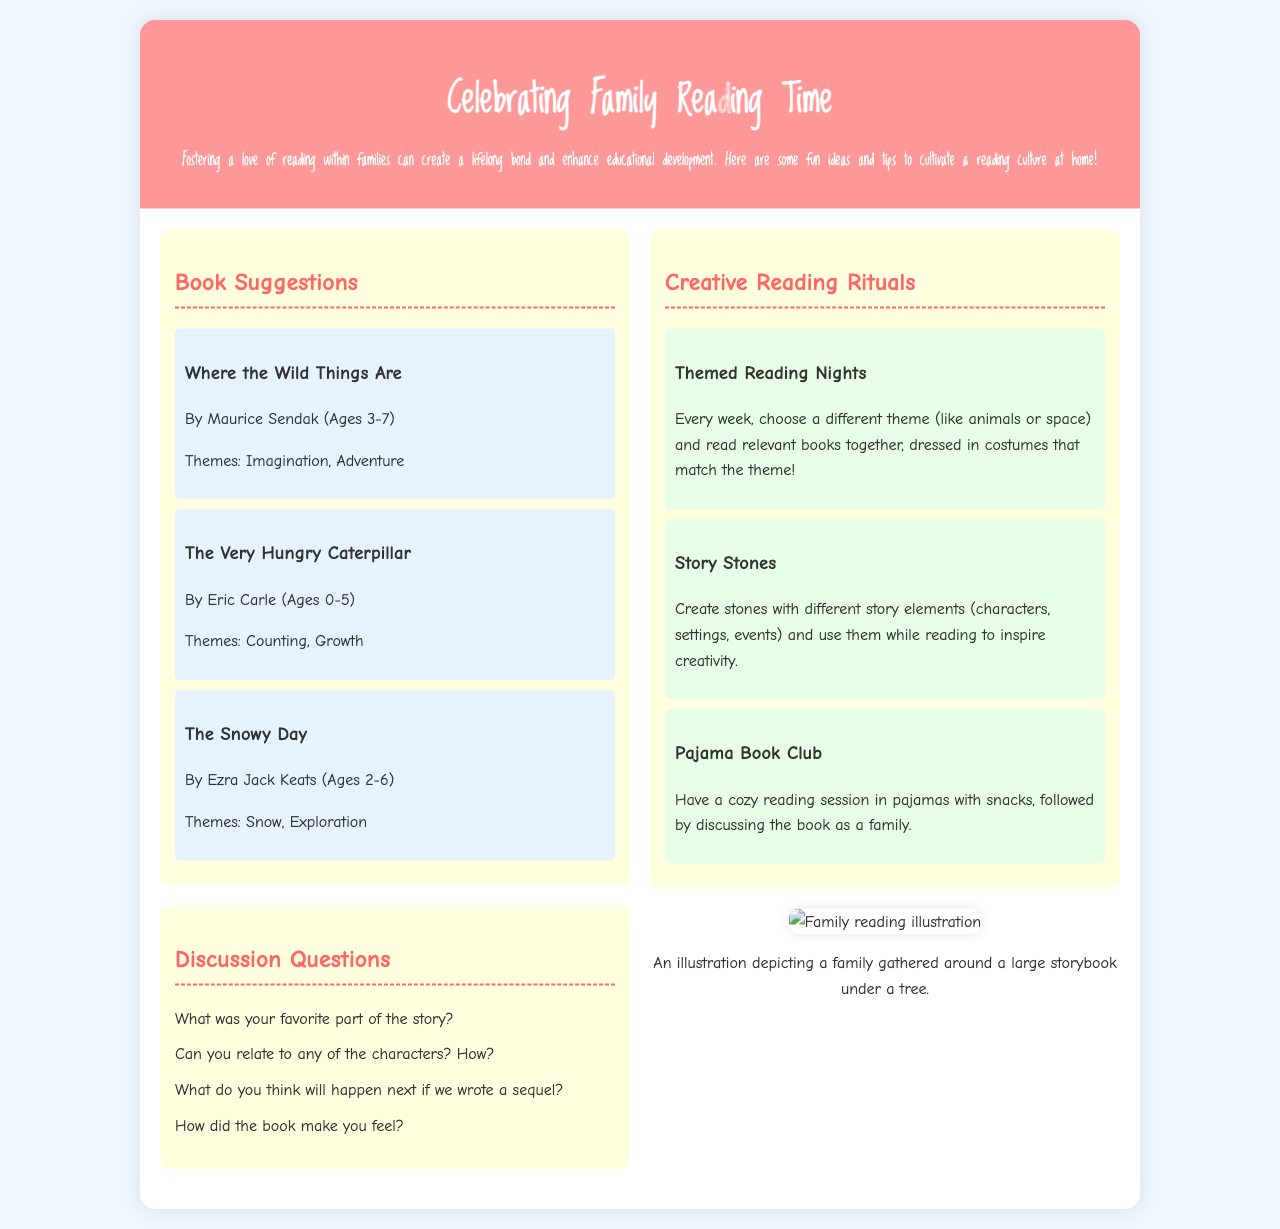What is the title of the brochure? The title is stated prominently at the top of the document in the header section.
Answer: Celebrating Family Reading Time What age range is suggested for "Where the Wild Things Are"? The age range is specified in the book suggestions section for each book.
Answer: Ages 3-7 What theme does "The Very Hungry Caterpillar" cover? The theme of the book is included in the description of the book suggestions.
Answer: Counting, Growth How many discussion questions are listed in the brochure? The total number of questions can be counted in the discussion questions section.
Answer: Four What is a suggested creative reading ritual? The document lists multiple creative reading rituals in their own section.
Answer: Themed Reading Nights What color is the background of the brochure? The color is mentioned in the body style section of the document.
Answer: Light blue (f0f8ff) How is the family reading illustration described? The description appears below the visual section and describes the illustration's content.
Answer: A family gathered around a large storybook under a tree What font is used for the header? The font is specified in the style section, defining the appearance of the header text.
Answer: Loved by the King What are "Story Stones"? The document describes these items in the section about creative reading rituals.
Answer: Stones with different story elements 